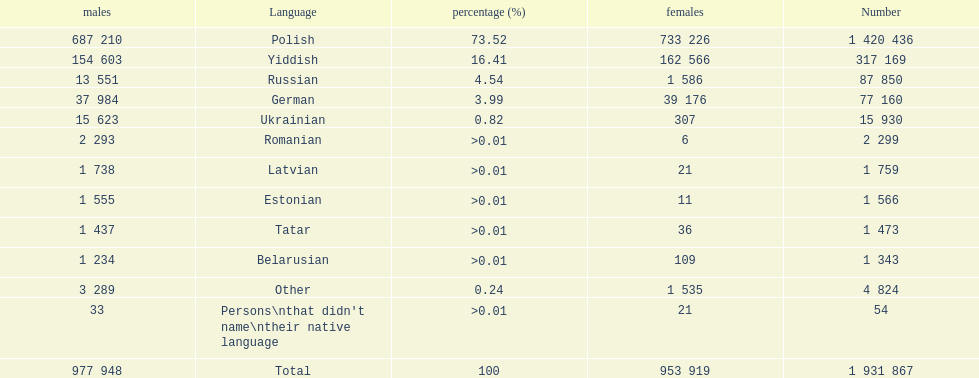Is german above or below russia in the number of people who speak that language? Below. 